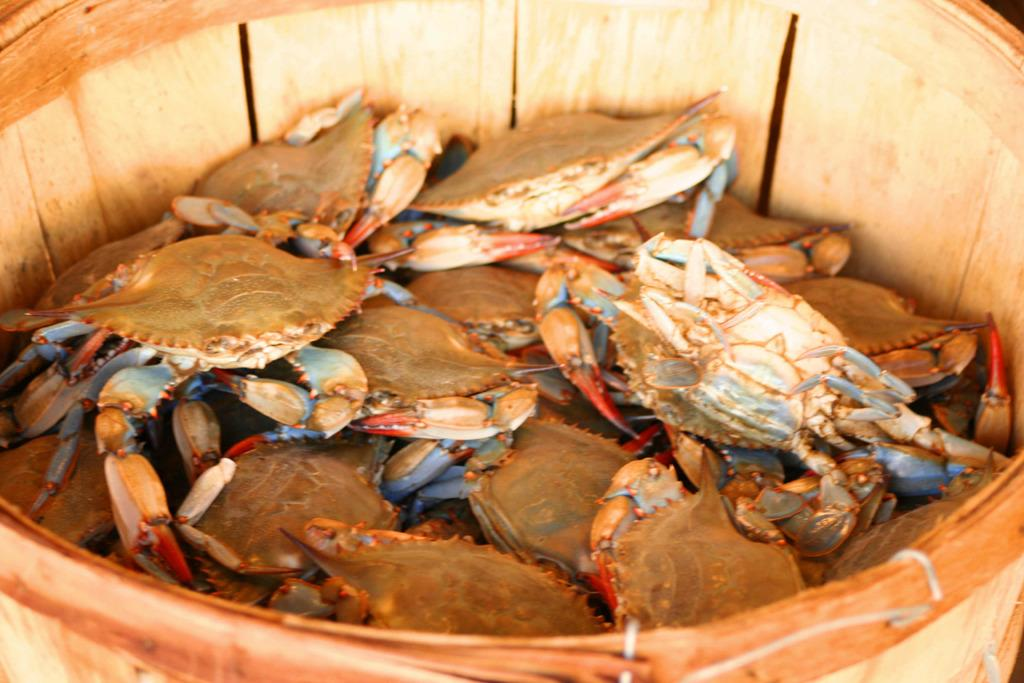What object can be seen in the image that is typically used for holding or carrying items? There is a bucket in the image. What is inside the bucket in the image? The bucket contains crabs. What type of wire can be seen connecting the crabs in the image? There is no wire present in the image; the crabs are contained within a bucket. 